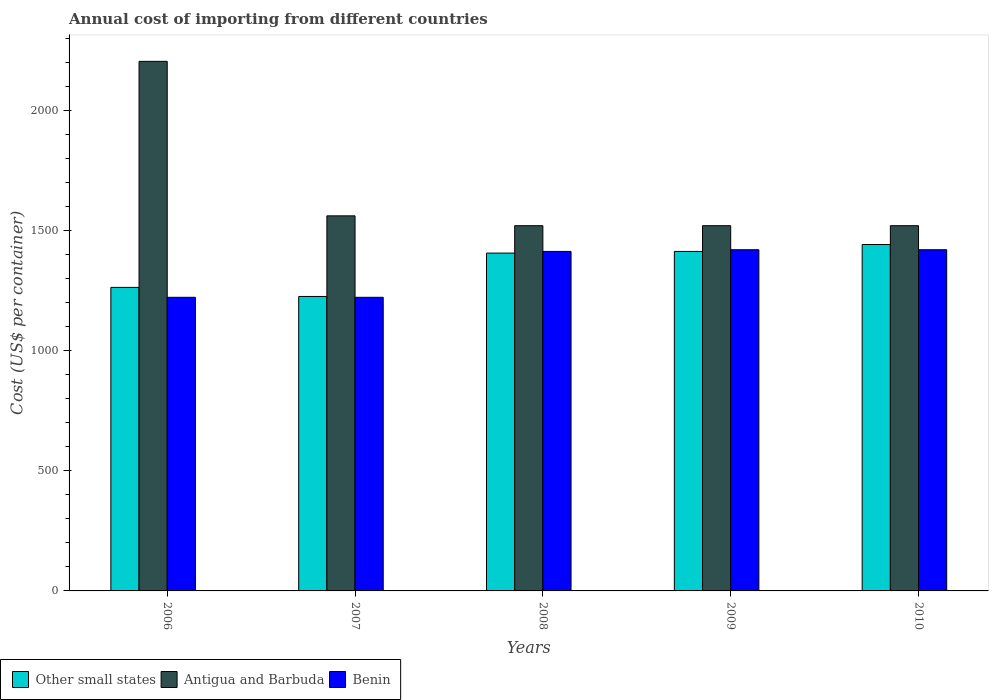How many different coloured bars are there?
Provide a succinct answer. 3. How many groups of bars are there?
Offer a very short reply. 5. What is the total annual cost of importing in Other small states in 2010?
Provide a succinct answer. 1441.67. Across all years, what is the maximum total annual cost of importing in Other small states?
Ensure brevity in your answer.  1441.67. Across all years, what is the minimum total annual cost of importing in Antigua and Barbuda?
Offer a very short reply. 1520. In which year was the total annual cost of importing in Other small states minimum?
Offer a very short reply. 2007. What is the total total annual cost of importing in Benin in the graph?
Ensure brevity in your answer.  6697. What is the difference between the total annual cost of importing in Other small states in 2007 and that in 2008?
Your response must be concise. -180.56. What is the difference between the total annual cost of importing in Benin in 2008 and the total annual cost of importing in Other small states in 2009?
Your answer should be compact. 0.06. What is the average total annual cost of importing in Other small states per year?
Offer a very short reply. 1349.89. In the year 2007, what is the difference between the total annual cost of importing in Benin and total annual cost of importing in Antigua and Barbuda?
Offer a very short reply. -339. Is the difference between the total annual cost of importing in Benin in 2006 and 2008 greater than the difference between the total annual cost of importing in Antigua and Barbuda in 2006 and 2008?
Ensure brevity in your answer.  No. What is the difference between the highest and the second highest total annual cost of importing in Benin?
Keep it short and to the point. 0. What is the difference between the highest and the lowest total annual cost of importing in Benin?
Offer a very short reply. 198. What does the 1st bar from the left in 2006 represents?
Your answer should be compact. Other small states. What does the 3rd bar from the right in 2006 represents?
Give a very brief answer. Other small states. Is it the case that in every year, the sum of the total annual cost of importing in Benin and total annual cost of importing in Antigua and Barbuda is greater than the total annual cost of importing in Other small states?
Your response must be concise. Yes. How many bars are there?
Your answer should be compact. 15. Are all the bars in the graph horizontal?
Your answer should be very brief. No. What is the difference between two consecutive major ticks on the Y-axis?
Provide a succinct answer. 500. Are the values on the major ticks of Y-axis written in scientific E-notation?
Give a very brief answer. No. Does the graph contain any zero values?
Offer a terse response. No. Does the graph contain grids?
Make the answer very short. No. Where does the legend appear in the graph?
Offer a terse response. Bottom left. What is the title of the graph?
Keep it short and to the point. Annual cost of importing from different countries. Does "Zimbabwe" appear as one of the legend labels in the graph?
Your response must be concise. No. What is the label or title of the Y-axis?
Provide a short and direct response. Cost (US$ per container). What is the Cost (US$ per container) of Other small states in 2006?
Offer a very short reply. 1263.28. What is the Cost (US$ per container) of Antigua and Barbuda in 2006?
Give a very brief answer. 2204. What is the Cost (US$ per container) of Benin in 2006?
Provide a short and direct response. 1222. What is the Cost (US$ per container) in Other small states in 2007?
Offer a very short reply. 1225.5. What is the Cost (US$ per container) of Antigua and Barbuda in 2007?
Your response must be concise. 1561. What is the Cost (US$ per container) in Benin in 2007?
Your response must be concise. 1222. What is the Cost (US$ per container) in Other small states in 2008?
Offer a very short reply. 1406.06. What is the Cost (US$ per container) of Antigua and Barbuda in 2008?
Ensure brevity in your answer.  1520. What is the Cost (US$ per container) in Benin in 2008?
Provide a succinct answer. 1413. What is the Cost (US$ per container) of Other small states in 2009?
Make the answer very short. 1412.94. What is the Cost (US$ per container) in Antigua and Barbuda in 2009?
Offer a terse response. 1520. What is the Cost (US$ per container) in Benin in 2009?
Ensure brevity in your answer.  1420. What is the Cost (US$ per container) of Other small states in 2010?
Your response must be concise. 1441.67. What is the Cost (US$ per container) in Antigua and Barbuda in 2010?
Provide a short and direct response. 1520. What is the Cost (US$ per container) of Benin in 2010?
Make the answer very short. 1420. Across all years, what is the maximum Cost (US$ per container) in Other small states?
Give a very brief answer. 1441.67. Across all years, what is the maximum Cost (US$ per container) in Antigua and Barbuda?
Offer a very short reply. 2204. Across all years, what is the maximum Cost (US$ per container) of Benin?
Your answer should be very brief. 1420. Across all years, what is the minimum Cost (US$ per container) of Other small states?
Make the answer very short. 1225.5. Across all years, what is the minimum Cost (US$ per container) in Antigua and Barbuda?
Provide a short and direct response. 1520. Across all years, what is the minimum Cost (US$ per container) of Benin?
Provide a succinct answer. 1222. What is the total Cost (US$ per container) of Other small states in the graph?
Keep it short and to the point. 6749.44. What is the total Cost (US$ per container) of Antigua and Barbuda in the graph?
Your answer should be very brief. 8325. What is the total Cost (US$ per container) in Benin in the graph?
Provide a succinct answer. 6697. What is the difference between the Cost (US$ per container) in Other small states in 2006 and that in 2007?
Your answer should be compact. 37.78. What is the difference between the Cost (US$ per container) in Antigua and Barbuda in 2006 and that in 2007?
Offer a terse response. 643. What is the difference between the Cost (US$ per container) of Other small states in 2006 and that in 2008?
Ensure brevity in your answer.  -142.78. What is the difference between the Cost (US$ per container) in Antigua and Barbuda in 2006 and that in 2008?
Provide a short and direct response. 684. What is the difference between the Cost (US$ per container) in Benin in 2006 and that in 2008?
Provide a succinct answer. -191. What is the difference between the Cost (US$ per container) of Other small states in 2006 and that in 2009?
Make the answer very short. -149.67. What is the difference between the Cost (US$ per container) in Antigua and Barbuda in 2006 and that in 2009?
Offer a terse response. 684. What is the difference between the Cost (US$ per container) of Benin in 2006 and that in 2009?
Your answer should be compact. -198. What is the difference between the Cost (US$ per container) in Other small states in 2006 and that in 2010?
Provide a short and direct response. -178.39. What is the difference between the Cost (US$ per container) of Antigua and Barbuda in 2006 and that in 2010?
Your answer should be very brief. 684. What is the difference between the Cost (US$ per container) of Benin in 2006 and that in 2010?
Your answer should be compact. -198. What is the difference between the Cost (US$ per container) of Other small states in 2007 and that in 2008?
Ensure brevity in your answer.  -180.56. What is the difference between the Cost (US$ per container) in Antigua and Barbuda in 2007 and that in 2008?
Your response must be concise. 41. What is the difference between the Cost (US$ per container) in Benin in 2007 and that in 2008?
Your response must be concise. -191. What is the difference between the Cost (US$ per container) in Other small states in 2007 and that in 2009?
Provide a succinct answer. -187.44. What is the difference between the Cost (US$ per container) of Benin in 2007 and that in 2009?
Offer a very short reply. -198. What is the difference between the Cost (US$ per container) in Other small states in 2007 and that in 2010?
Provide a succinct answer. -216.17. What is the difference between the Cost (US$ per container) of Benin in 2007 and that in 2010?
Offer a terse response. -198. What is the difference between the Cost (US$ per container) of Other small states in 2008 and that in 2009?
Ensure brevity in your answer.  -6.89. What is the difference between the Cost (US$ per container) in Antigua and Barbuda in 2008 and that in 2009?
Your answer should be compact. 0. What is the difference between the Cost (US$ per container) of Other small states in 2008 and that in 2010?
Give a very brief answer. -35.61. What is the difference between the Cost (US$ per container) in Benin in 2008 and that in 2010?
Keep it short and to the point. -7. What is the difference between the Cost (US$ per container) of Other small states in 2009 and that in 2010?
Make the answer very short. -28.72. What is the difference between the Cost (US$ per container) in Antigua and Barbuda in 2009 and that in 2010?
Provide a succinct answer. 0. What is the difference between the Cost (US$ per container) in Benin in 2009 and that in 2010?
Provide a short and direct response. 0. What is the difference between the Cost (US$ per container) of Other small states in 2006 and the Cost (US$ per container) of Antigua and Barbuda in 2007?
Offer a very short reply. -297.72. What is the difference between the Cost (US$ per container) of Other small states in 2006 and the Cost (US$ per container) of Benin in 2007?
Provide a short and direct response. 41.28. What is the difference between the Cost (US$ per container) of Antigua and Barbuda in 2006 and the Cost (US$ per container) of Benin in 2007?
Ensure brevity in your answer.  982. What is the difference between the Cost (US$ per container) of Other small states in 2006 and the Cost (US$ per container) of Antigua and Barbuda in 2008?
Provide a succinct answer. -256.72. What is the difference between the Cost (US$ per container) of Other small states in 2006 and the Cost (US$ per container) of Benin in 2008?
Ensure brevity in your answer.  -149.72. What is the difference between the Cost (US$ per container) of Antigua and Barbuda in 2006 and the Cost (US$ per container) of Benin in 2008?
Make the answer very short. 791. What is the difference between the Cost (US$ per container) of Other small states in 2006 and the Cost (US$ per container) of Antigua and Barbuda in 2009?
Provide a succinct answer. -256.72. What is the difference between the Cost (US$ per container) of Other small states in 2006 and the Cost (US$ per container) of Benin in 2009?
Provide a succinct answer. -156.72. What is the difference between the Cost (US$ per container) of Antigua and Barbuda in 2006 and the Cost (US$ per container) of Benin in 2009?
Keep it short and to the point. 784. What is the difference between the Cost (US$ per container) of Other small states in 2006 and the Cost (US$ per container) of Antigua and Barbuda in 2010?
Keep it short and to the point. -256.72. What is the difference between the Cost (US$ per container) in Other small states in 2006 and the Cost (US$ per container) in Benin in 2010?
Keep it short and to the point. -156.72. What is the difference between the Cost (US$ per container) in Antigua and Barbuda in 2006 and the Cost (US$ per container) in Benin in 2010?
Ensure brevity in your answer.  784. What is the difference between the Cost (US$ per container) in Other small states in 2007 and the Cost (US$ per container) in Antigua and Barbuda in 2008?
Keep it short and to the point. -294.5. What is the difference between the Cost (US$ per container) of Other small states in 2007 and the Cost (US$ per container) of Benin in 2008?
Provide a short and direct response. -187.5. What is the difference between the Cost (US$ per container) in Antigua and Barbuda in 2007 and the Cost (US$ per container) in Benin in 2008?
Offer a terse response. 148. What is the difference between the Cost (US$ per container) of Other small states in 2007 and the Cost (US$ per container) of Antigua and Barbuda in 2009?
Make the answer very short. -294.5. What is the difference between the Cost (US$ per container) of Other small states in 2007 and the Cost (US$ per container) of Benin in 2009?
Provide a short and direct response. -194.5. What is the difference between the Cost (US$ per container) in Antigua and Barbuda in 2007 and the Cost (US$ per container) in Benin in 2009?
Keep it short and to the point. 141. What is the difference between the Cost (US$ per container) of Other small states in 2007 and the Cost (US$ per container) of Antigua and Barbuda in 2010?
Your response must be concise. -294.5. What is the difference between the Cost (US$ per container) in Other small states in 2007 and the Cost (US$ per container) in Benin in 2010?
Your response must be concise. -194.5. What is the difference between the Cost (US$ per container) of Antigua and Barbuda in 2007 and the Cost (US$ per container) of Benin in 2010?
Make the answer very short. 141. What is the difference between the Cost (US$ per container) of Other small states in 2008 and the Cost (US$ per container) of Antigua and Barbuda in 2009?
Provide a short and direct response. -113.94. What is the difference between the Cost (US$ per container) of Other small states in 2008 and the Cost (US$ per container) of Benin in 2009?
Provide a short and direct response. -13.94. What is the difference between the Cost (US$ per container) of Other small states in 2008 and the Cost (US$ per container) of Antigua and Barbuda in 2010?
Keep it short and to the point. -113.94. What is the difference between the Cost (US$ per container) in Other small states in 2008 and the Cost (US$ per container) in Benin in 2010?
Your answer should be very brief. -13.94. What is the difference between the Cost (US$ per container) of Antigua and Barbuda in 2008 and the Cost (US$ per container) of Benin in 2010?
Your answer should be very brief. 100. What is the difference between the Cost (US$ per container) of Other small states in 2009 and the Cost (US$ per container) of Antigua and Barbuda in 2010?
Make the answer very short. -107.06. What is the difference between the Cost (US$ per container) in Other small states in 2009 and the Cost (US$ per container) in Benin in 2010?
Provide a succinct answer. -7.06. What is the difference between the Cost (US$ per container) of Antigua and Barbuda in 2009 and the Cost (US$ per container) of Benin in 2010?
Your answer should be compact. 100. What is the average Cost (US$ per container) of Other small states per year?
Your answer should be compact. 1349.89. What is the average Cost (US$ per container) in Antigua and Barbuda per year?
Your answer should be compact. 1665. What is the average Cost (US$ per container) of Benin per year?
Keep it short and to the point. 1339.4. In the year 2006, what is the difference between the Cost (US$ per container) of Other small states and Cost (US$ per container) of Antigua and Barbuda?
Make the answer very short. -940.72. In the year 2006, what is the difference between the Cost (US$ per container) in Other small states and Cost (US$ per container) in Benin?
Your response must be concise. 41.28. In the year 2006, what is the difference between the Cost (US$ per container) in Antigua and Barbuda and Cost (US$ per container) in Benin?
Keep it short and to the point. 982. In the year 2007, what is the difference between the Cost (US$ per container) of Other small states and Cost (US$ per container) of Antigua and Barbuda?
Offer a terse response. -335.5. In the year 2007, what is the difference between the Cost (US$ per container) in Other small states and Cost (US$ per container) in Benin?
Your answer should be compact. 3.5. In the year 2007, what is the difference between the Cost (US$ per container) of Antigua and Barbuda and Cost (US$ per container) of Benin?
Your answer should be very brief. 339. In the year 2008, what is the difference between the Cost (US$ per container) of Other small states and Cost (US$ per container) of Antigua and Barbuda?
Provide a short and direct response. -113.94. In the year 2008, what is the difference between the Cost (US$ per container) in Other small states and Cost (US$ per container) in Benin?
Make the answer very short. -6.94. In the year 2008, what is the difference between the Cost (US$ per container) of Antigua and Barbuda and Cost (US$ per container) of Benin?
Keep it short and to the point. 107. In the year 2009, what is the difference between the Cost (US$ per container) of Other small states and Cost (US$ per container) of Antigua and Barbuda?
Your answer should be compact. -107.06. In the year 2009, what is the difference between the Cost (US$ per container) of Other small states and Cost (US$ per container) of Benin?
Make the answer very short. -7.06. In the year 2010, what is the difference between the Cost (US$ per container) of Other small states and Cost (US$ per container) of Antigua and Barbuda?
Ensure brevity in your answer.  -78.33. In the year 2010, what is the difference between the Cost (US$ per container) of Other small states and Cost (US$ per container) of Benin?
Your answer should be compact. 21.67. In the year 2010, what is the difference between the Cost (US$ per container) of Antigua and Barbuda and Cost (US$ per container) of Benin?
Provide a short and direct response. 100. What is the ratio of the Cost (US$ per container) of Other small states in 2006 to that in 2007?
Offer a terse response. 1.03. What is the ratio of the Cost (US$ per container) in Antigua and Barbuda in 2006 to that in 2007?
Keep it short and to the point. 1.41. What is the ratio of the Cost (US$ per container) in Benin in 2006 to that in 2007?
Your answer should be compact. 1. What is the ratio of the Cost (US$ per container) in Other small states in 2006 to that in 2008?
Provide a succinct answer. 0.9. What is the ratio of the Cost (US$ per container) in Antigua and Barbuda in 2006 to that in 2008?
Offer a very short reply. 1.45. What is the ratio of the Cost (US$ per container) in Benin in 2006 to that in 2008?
Your response must be concise. 0.86. What is the ratio of the Cost (US$ per container) of Other small states in 2006 to that in 2009?
Your response must be concise. 0.89. What is the ratio of the Cost (US$ per container) of Antigua and Barbuda in 2006 to that in 2009?
Ensure brevity in your answer.  1.45. What is the ratio of the Cost (US$ per container) of Benin in 2006 to that in 2009?
Ensure brevity in your answer.  0.86. What is the ratio of the Cost (US$ per container) in Other small states in 2006 to that in 2010?
Provide a short and direct response. 0.88. What is the ratio of the Cost (US$ per container) of Antigua and Barbuda in 2006 to that in 2010?
Give a very brief answer. 1.45. What is the ratio of the Cost (US$ per container) in Benin in 2006 to that in 2010?
Ensure brevity in your answer.  0.86. What is the ratio of the Cost (US$ per container) of Other small states in 2007 to that in 2008?
Provide a short and direct response. 0.87. What is the ratio of the Cost (US$ per container) in Antigua and Barbuda in 2007 to that in 2008?
Offer a terse response. 1.03. What is the ratio of the Cost (US$ per container) in Benin in 2007 to that in 2008?
Offer a terse response. 0.86. What is the ratio of the Cost (US$ per container) in Other small states in 2007 to that in 2009?
Offer a terse response. 0.87. What is the ratio of the Cost (US$ per container) of Benin in 2007 to that in 2009?
Your answer should be compact. 0.86. What is the ratio of the Cost (US$ per container) in Other small states in 2007 to that in 2010?
Make the answer very short. 0.85. What is the ratio of the Cost (US$ per container) in Antigua and Barbuda in 2007 to that in 2010?
Keep it short and to the point. 1.03. What is the ratio of the Cost (US$ per container) in Benin in 2007 to that in 2010?
Ensure brevity in your answer.  0.86. What is the ratio of the Cost (US$ per container) of Other small states in 2008 to that in 2009?
Ensure brevity in your answer.  1. What is the ratio of the Cost (US$ per container) of Benin in 2008 to that in 2009?
Your response must be concise. 1. What is the ratio of the Cost (US$ per container) of Other small states in 2008 to that in 2010?
Offer a terse response. 0.98. What is the ratio of the Cost (US$ per container) of Benin in 2008 to that in 2010?
Your response must be concise. 1. What is the ratio of the Cost (US$ per container) of Other small states in 2009 to that in 2010?
Offer a terse response. 0.98. What is the ratio of the Cost (US$ per container) of Benin in 2009 to that in 2010?
Offer a very short reply. 1. What is the difference between the highest and the second highest Cost (US$ per container) in Other small states?
Ensure brevity in your answer.  28.72. What is the difference between the highest and the second highest Cost (US$ per container) in Antigua and Barbuda?
Give a very brief answer. 643. What is the difference between the highest and the lowest Cost (US$ per container) in Other small states?
Ensure brevity in your answer.  216.17. What is the difference between the highest and the lowest Cost (US$ per container) in Antigua and Barbuda?
Offer a very short reply. 684. What is the difference between the highest and the lowest Cost (US$ per container) in Benin?
Your answer should be very brief. 198. 